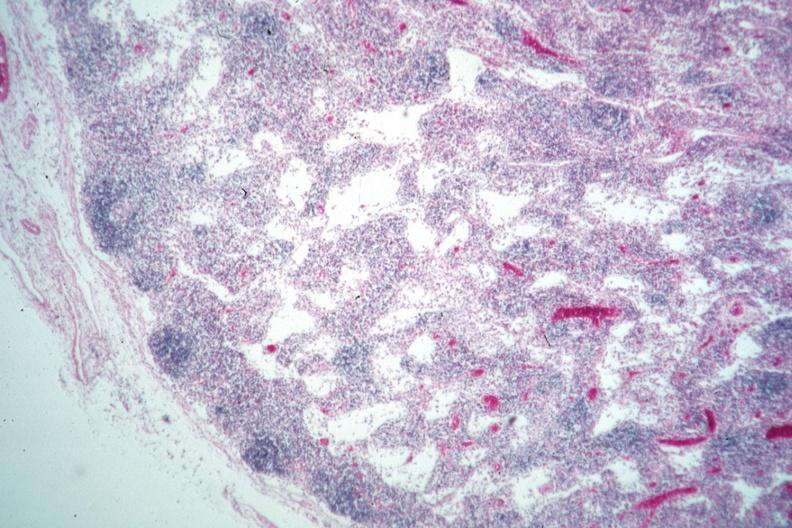what is present?
Answer the question using a single word or phrase. Di george syndrome 